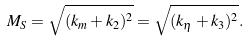<formula> <loc_0><loc_0><loc_500><loc_500>M _ { S } = \sqrt { ( k _ { m } + k _ { 2 } ) ^ { 2 } } = \sqrt { ( k _ { \eta } + k _ { 3 } ) ^ { 2 } } .</formula> 